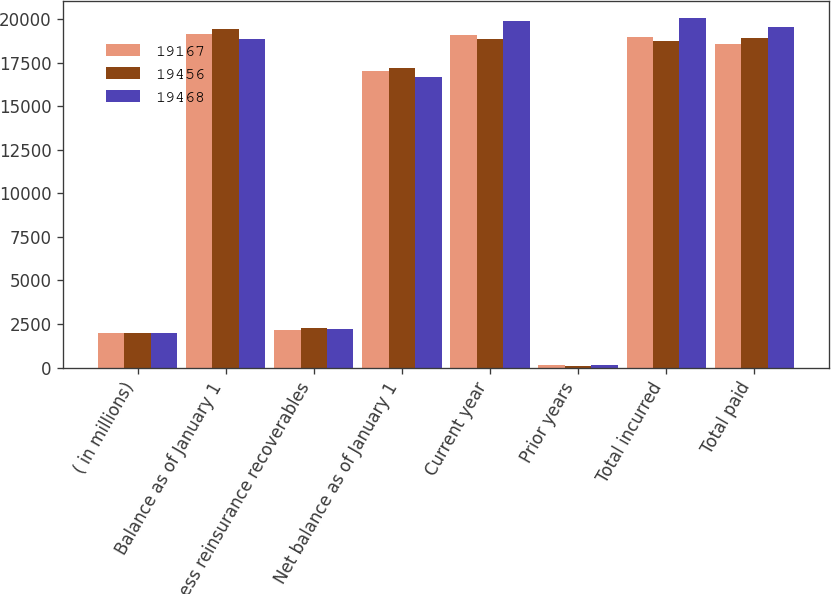Convert chart. <chart><loc_0><loc_0><loc_500><loc_500><stacked_bar_chart><ecel><fcel>( in millions)<fcel>Balance as of January 1<fcel>Less reinsurance recoverables<fcel>Net balance as of January 1<fcel>Current year<fcel>Prior years<fcel>Total incurred<fcel>Total paid<nl><fcel>19167<fcel>2010<fcel>19167<fcel>2139<fcel>17028<fcel>19110<fcel>159<fcel>18951<fcel>18583<nl><fcel>19456<fcel>2009<fcel>19456<fcel>2274<fcel>17182<fcel>18858<fcel>112<fcel>18746<fcel>18900<nl><fcel>19468<fcel>2008<fcel>18865<fcel>2205<fcel>16660<fcel>19894<fcel>170<fcel>20064<fcel>19542<nl></chart> 